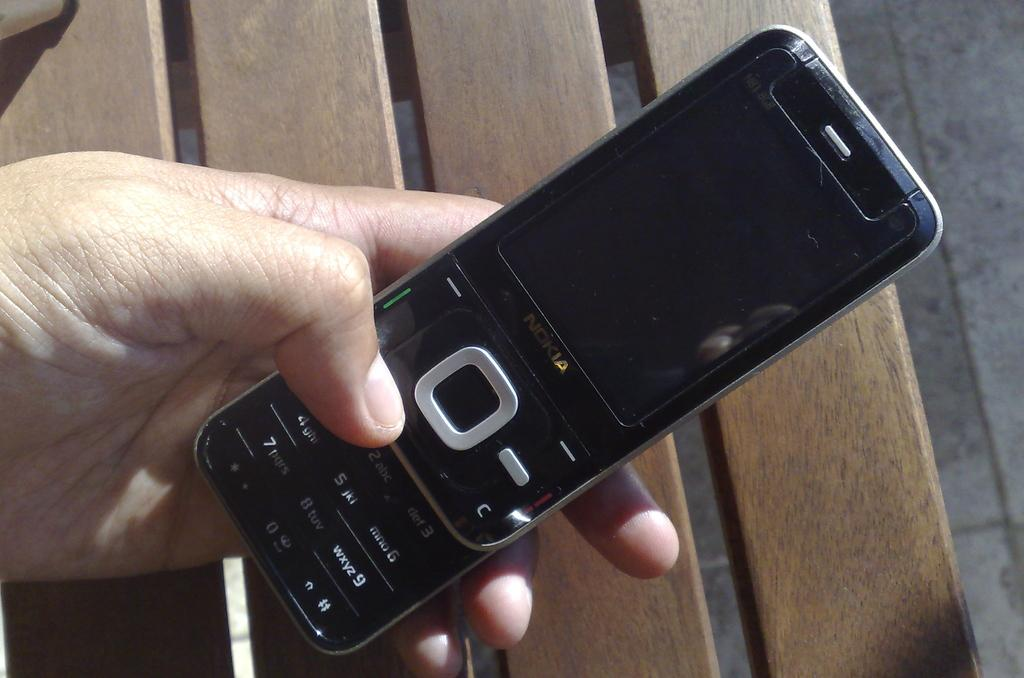<image>
Create a compact narrative representing the image presented. A Nokia slide phone with the keypad slid open being held over bench in the background. 